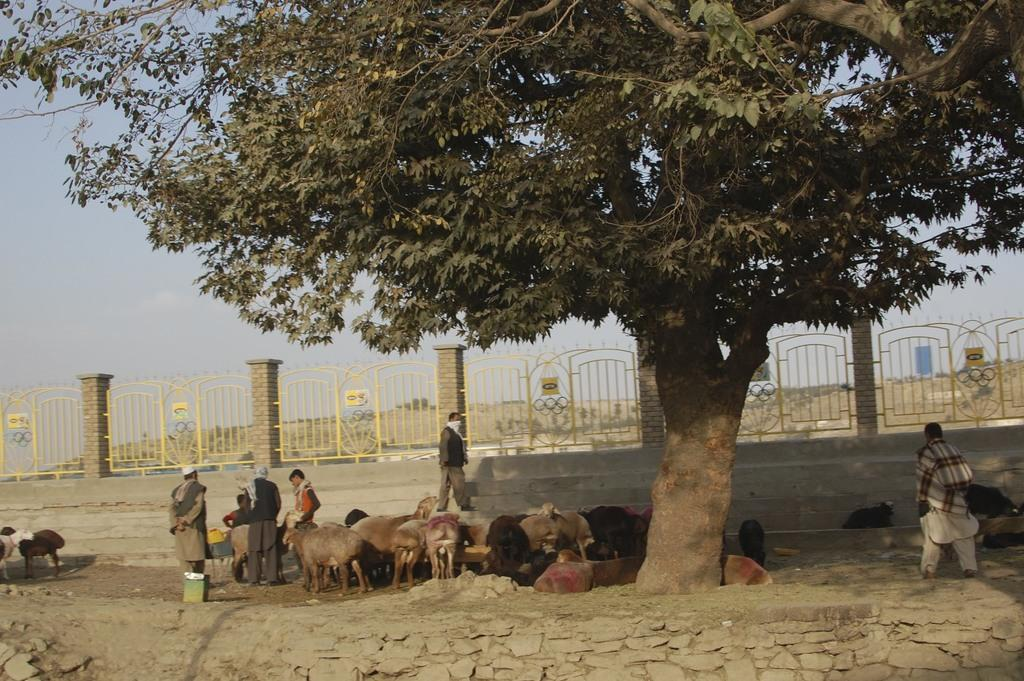Who or what can be seen in the image? There are people and animals in the image. Where are the people and animals located? They are under a tree in the image. What else is visible in the image? There is a wall visible in the image. What type of linen is being used by the animals in the image? There is no linen present in the image, and the animals are not using any linen. 